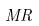<formula> <loc_0><loc_0><loc_500><loc_500>M R</formula> 